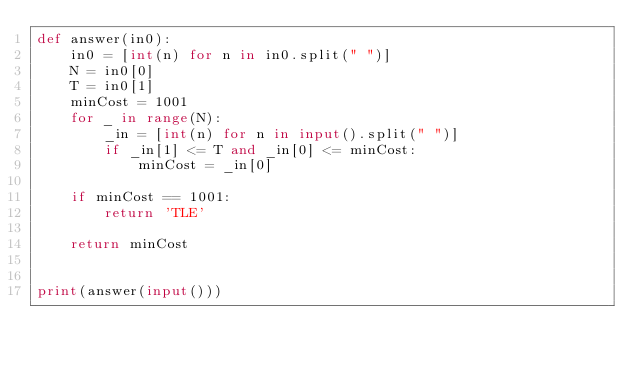Convert code to text. <code><loc_0><loc_0><loc_500><loc_500><_Python_>def answer(in0):
    in0 = [int(n) for n in in0.split(" ")]
    N = in0[0]
    T = in0[1]
    minCost = 1001
    for _ in range(N):
        _in = [int(n) for n in input().split(" ")]
        if _in[1] <= T and _in[0] <= minCost:
            minCost = _in[0]

    if minCost == 1001:
        return 'TLE'

    return minCost


print(answer(input()))
</code> 